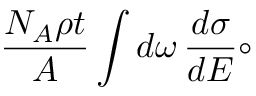Convert formula to latex. <formula><loc_0><loc_0><loc_500><loc_500>\frac { N _ { A } \rho t } { A } \int d \omega \, \frac { d \sigma } { d E } \circ</formula> 